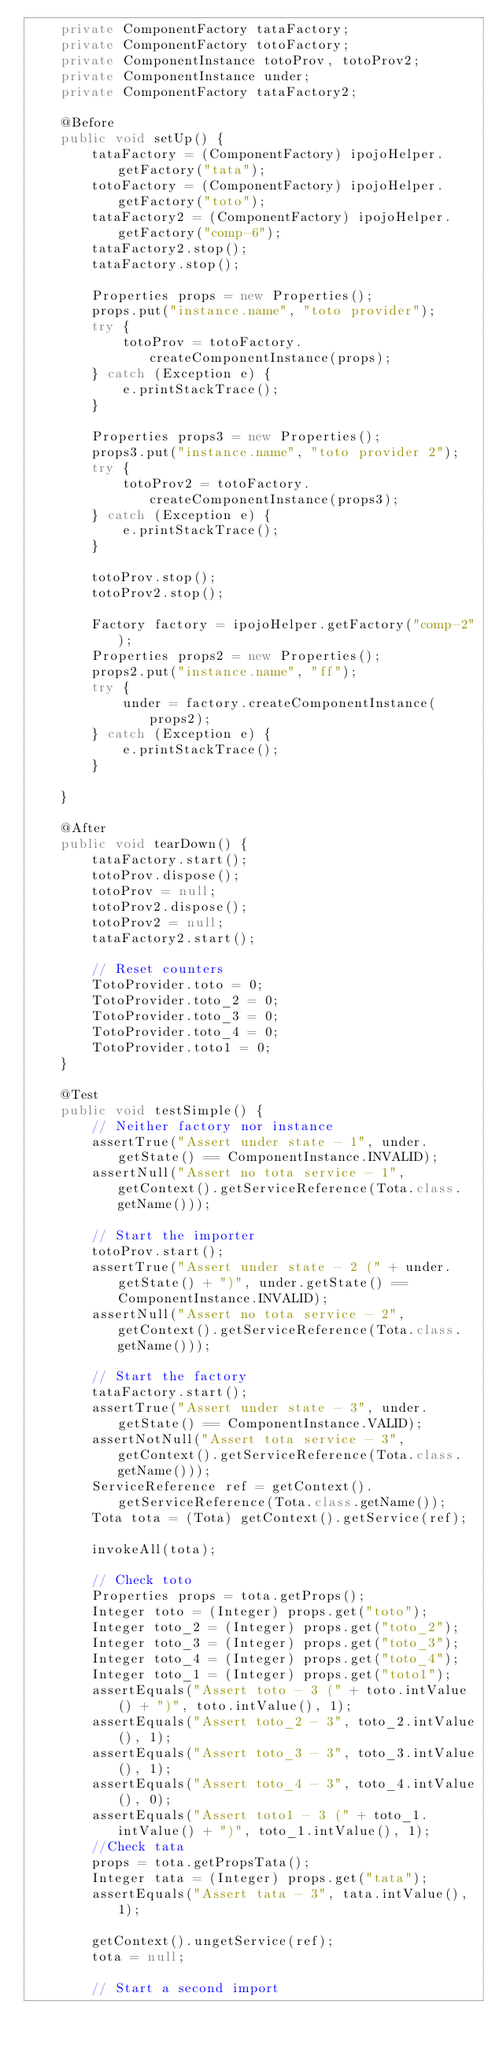<code> <loc_0><loc_0><loc_500><loc_500><_Java_>    private ComponentFactory tataFactory;
    private ComponentFactory totoFactory;
    private ComponentInstance totoProv, totoProv2;
    private ComponentInstance under;
    private ComponentFactory tataFactory2;

    @Before
    public void setUp() {
        tataFactory = (ComponentFactory) ipojoHelper.getFactory("tata");
        totoFactory = (ComponentFactory) ipojoHelper.getFactory("toto");
        tataFactory2 = (ComponentFactory) ipojoHelper.getFactory("comp-6");
        tataFactory2.stop();
        tataFactory.stop();

        Properties props = new Properties();
        props.put("instance.name", "toto provider");
        try {
            totoProv = totoFactory.createComponentInstance(props);
        } catch (Exception e) {
            e.printStackTrace();
        }

        Properties props3 = new Properties();
        props3.put("instance.name", "toto provider 2");
        try {
            totoProv2 = totoFactory.createComponentInstance(props3);
        } catch (Exception e) {
            e.printStackTrace();
        }

        totoProv.stop();
        totoProv2.stop();

        Factory factory = ipojoHelper.getFactory("comp-2");
        Properties props2 = new Properties();
        props2.put("instance.name", "ff");
        try {
            under = factory.createComponentInstance(props2);
        } catch (Exception e) {
            e.printStackTrace();
        }

    }

    @After
    public void tearDown() {
        tataFactory.start();
        totoProv.dispose();
        totoProv = null;
        totoProv2.dispose();
        totoProv2 = null;
        tataFactory2.start();

        // Reset counters
        TotoProvider.toto = 0;
        TotoProvider.toto_2 = 0;
        TotoProvider.toto_3 = 0;
        TotoProvider.toto_4 = 0;
        TotoProvider.toto1 = 0;
    }

    @Test
    public void testSimple() {
        // Neither factory nor instance
        assertTrue("Assert under state - 1", under.getState() == ComponentInstance.INVALID);
        assertNull("Assert no tota service - 1", getContext().getServiceReference(Tota.class.getName()));

        // Start the importer
        totoProv.start();
        assertTrue("Assert under state - 2 (" + under.getState() + ")", under.getState() == ComponentInstance.INVALID);
        assertNull("Assert no tota service - 2", getContext().getServiceReference(Tota.class.getName()));

        // Start the factory
        tataFactory.start();
        assertTrue("Assert under state - 3", under.getState() == ComponentInstance.VALID);
        assertNotNull("Assert tota service - 3", getContext().getServiceReference(Tota.class.getName()));
        ServiceReference ref = getContext().getServiceReference(Tota.class.getName());
        Tota tota = (Tota) getContext().getService(ref);

        invokeAll(tota);

        // Check toto
        Properties props = tota.getProps();
        Integer toto = (Integer) props.get("toto");
        Integer toto_2 = (Integer) props.get("toto_2");
        Integer toto_3 = (Integer) props.get("toto_3");
        Integer toto_4 = (Integer) props.get("toto_4");
        Integer toto_1 = (Integer) props.get("toto1");
        assertEquals("Assert toto - 3 (" + toto.intValue() + ")", toto.intValue(), 1);
        assertEquals("Assert toto_2 - 3", toto_2.intValue(), 1);
        assertEquals("Assert toto_3 - 3", toto_3.intValue(), 1);
        assertEquals("Assert toto_4 - 3", toto_4.intValue(), 0);
        assertEquals("Assert toto1 - 3 (" + toto_1.intValue() + ")", toto_1.intValue(), 1);
        //Check tata
        props = tota.getPropsTata();
        Integer tata = (Integer) props.get("tata");
        assertEquals("Assert tata - 3", tata.intValue(), 1);

        getContext().ungetService(ref);
        tota = null;

        // Start a second import</code> 